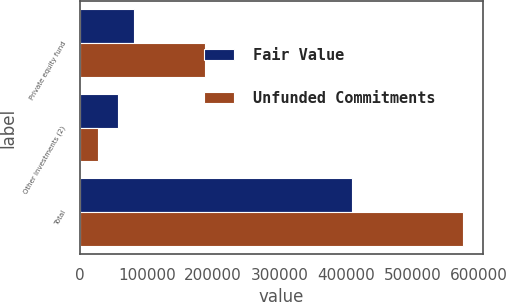Convert chart. <chart><loc_0><loc_0><loc_500><loc_500><stacked_bar_chart><ecel><fcel>Private equity fund<fcel>Other investments (2)<fcel>Total<nl><fcel>Fair Value<fcel>81015<fcel>56242<fcel>408573<nl><fcel>Unfunded Commitments<fcel>187361<fcel>26040<fcel>576131<nl></chart> 